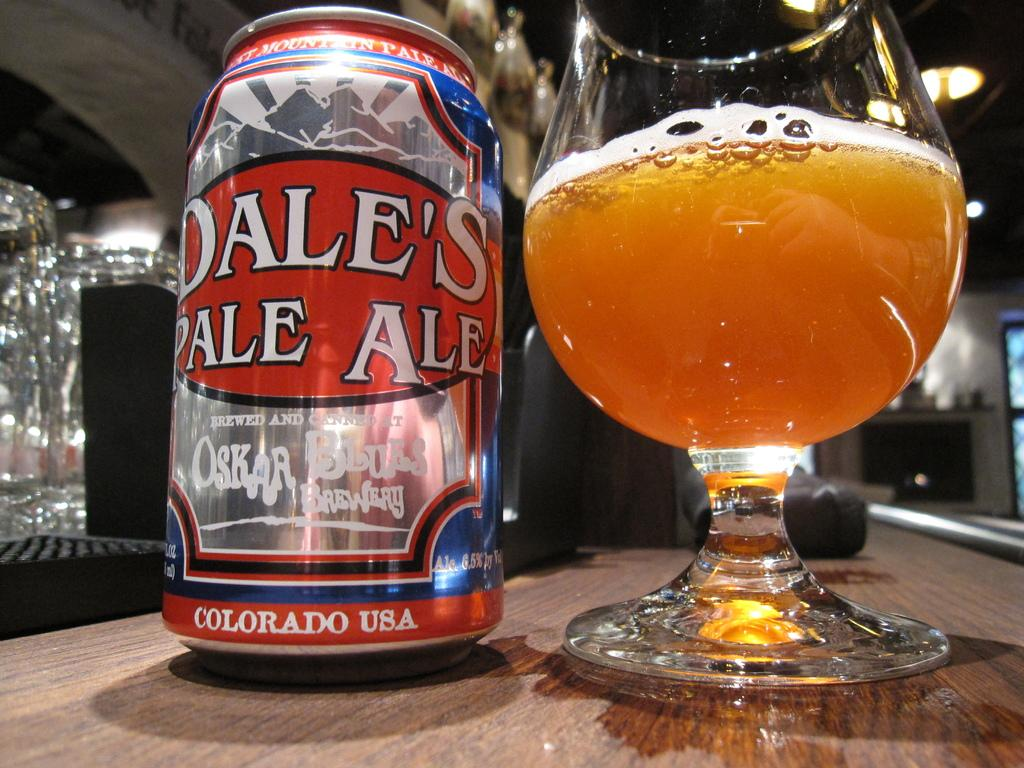<image>
Provide a brief description of the given image. A can of Dale's Pale Ale sits on a table next to a half-full glass. 